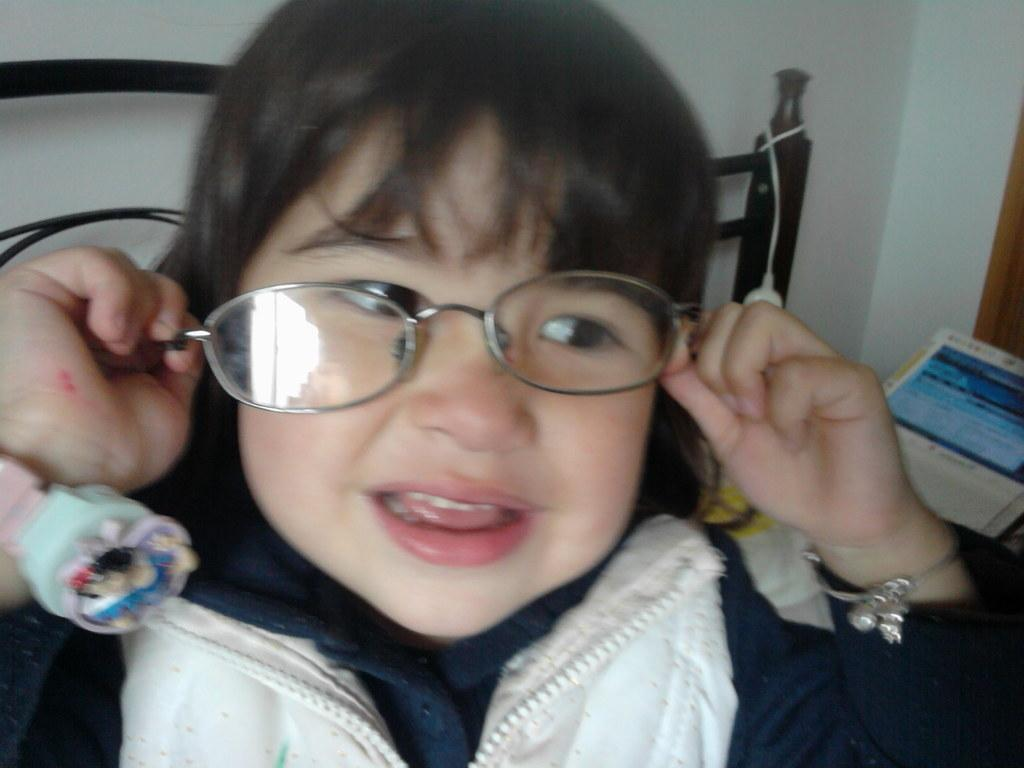What is the main subject in the front of the image? There is a kid in the front of the image. What is the kid wearing? The kid is wearing spectacles. What can be seen on the right side of the image? There appears to be a book on the right side of the image. What is visible in the background of the image? There is a wall in the background of the image. What type of bird can be seen flying near the wall in the image? There is no bird present in the image; it only features a kid, spectacles, a book, and a wall. 